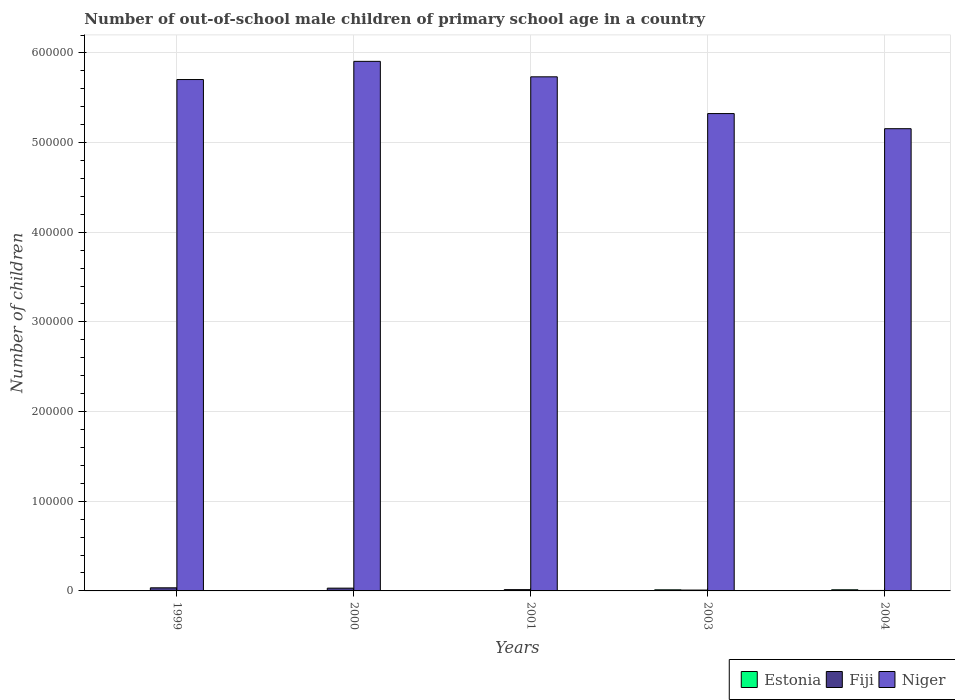How many groups of bars are there?
Make the answer very short. 5. What is the label of the 4th group of bars from the left?
Make the answer very short. 2003. What is the number of out-of-school male children in Niger in 1999?
Offer a very short reply. 5.70e+05. Across all years, what is the maximum number of out-of-school male children in Estonia?
Make the answer very short. 1269. Across all years, what is the minimum number of out-of-school male children in Niger?
Give a very brief answer. 5.16e+05. In which year was the number of out-of-school male children in Fiji minimum?
Make the answer very short. 2004. What is the total number of out-of-school male children in Niger in the graph?
Keep it short and to the point. 2.78e+06. What is the difference between the number of out-of-school male children in Estonia in 2003 and the number of out-of-school male children in Niger in 1999?
Make the answer very short. -5.69e+05. What is the average number of out-of-school male children in Estonia per year?
Ensure brevity in your answer.  509. In the year 2003, what is the difference between the number of out-of-school male children in Estonia and number of out-of-school male children in Niger?
Ensure brevity in your answer.  -5.31e+05. What is the ratio of the number of out-of-school male children in Estonia in 1999 to that in 2004?
Your answer should be compact. 0.02. Is the difference between the number of out-of-school male children in Estonia in 2000 and 2004 greater than the difference between the number of out-of-school male children in Niger in 2000 and 2004?
Ensure brevity in your answer.  No. What is the difference between the highest and the second highest number of out-of-school male children in Niger?
Your answer should be compact. 1.72e+04. What is the difference between the highest and the lowest number of out-of-school male children in Fiji?
Make the answer very short. 2933. What does the 3rd bar from the left in 2001 represents?
Make the answer very short. Niger. What does the 2nd bar from the right in 2001 represents?
Ensure brevity in your answer.  Fiji. How many bars are there?
Make the answer very short. 15. Are all the bars in the graph horizontal?
Your answer should be compact. No. Are the values on the major ticks of Y-axis written in scientific E-notation?
Your answer should be compact. No. Does the graph contain grids?
Offer a very short reply. Yes. How are the legend labels stacked?
Give a very brief answer. Horizontal. What is the title of the graph?
Offer a terse response. Number of out-of-school male children of primary school age in a country. What is the label or title of the Y-axis?
Give a very brief answer. Number of children. What is the Number of children in Estonia in 1999?
Make the answer very short. 27. What is the Number of children in Fiji in 1999?
Provide a succinct answer. 3458. What is the Number of children in Niger in 1999?
Give a very brief answer. 5.70e+05. What is the Number of children of Estonia in 2000?
Your answer should be very brief. 17. What is the Number of children of Fiji in 2000?
Your answer should be very brief. 3094. What is the Number of children of Niger in 2000?
Your answer should be compact. 5.91e+05. What is the Number of children in Fiji in 2001?
Your answer should be very brief. 1433. What is the Number of children in Niger in 2001?
Your answer should be very brief. 5.73e+05. What is the Number of children in Estonia in 2003?
Offer a very short reply. 1222. What is the Number of children in Fiji in 2003?
Give a very brief answer. 957. What is the Number of children in Niger in 2003?
Offer a terse response. 5.32e+05. What is the Number of children in Estonia in 2004?
Your response must be concise. 1269. What is the Number of children in Fiji in 2004?
Give a very brief answer. 525. What is the Number of children of Niger in 2004?
Make the answer very short. 5.16e+05. Across all years, what is the maximum Number of children in Estonia?
Offer a very short reply. 1269. Across all years, what is the maximum Number of children of Fiji?
Your answer should be very brief. 3458. Across all years, what is the maximum Number of children in Niger?
Offer a very short reply. 5.91e+05. Across all years, what is the minimum Number of children in Fiji?
Your response must be concise. 525. Across all years, what is the minimum Number of children of Niger?
Provide a short and direct response. 5.16e+05. What is the total Number of children of Estonia in the graph?
Offer a terse response. 2545. What is the total Number of children in Fiji in the graph?
Offer a very short reply. 9467. What is the total Number of children in Niger in the graph?
Ensure brevity in your answer.  2.78e+06. What is the difference between the Number of children of Fiji in 1999 and that in 2000?
Offer a terse response. 364. What is the difference between the Number of children in Niger in 1999 and that in 2000?
Offer a very short reply. -2.03e+04. What is the difference between the Number of children in Estonia in 1999 and that in 2001?
Make the answer very short. 17. What is the difference between the Number of children of Fiji in 1999 and that in 2001?
Make the answer very short. 2025. What is the difference between the Number of children of Niger in 1999 and that in 2001?
Make the answer very short. -3041. What is the difference between the Number of children in Estonia in 1999 and that in 2003?
Provide a short and direct response. -1195. What is the difference between the Number of children of Fiji in 1999 and that in 2003?
Give a very brief answer. 2501. What is the difference between the Number of children of Niger in 1999 and that in 2003?
Provide a short and direct response. 3.80e+04. What is the difference between the Number of children of Estonia in 1999 and that in 2004?
Give a very brief answer. -1242. What is the difference between the Number of children of Fiji in 1999 and that in 2004?
Offer a terse response. 2933. What is the difference between the Number of children in Niger in 1999 and that in 2004?
Offer a terse response. 5.48e+04. What is the difference between the Number of children of Fiji in 2000 and that in 2001?
Provide a short and direct response. 1661. What is the difference between the Number of children in Niger in 2000 and that in 2001?
Offer a terse response. 1.72e+04. What is the difference between the Number of children in Estonia in 2000 and that in 2003?
Offer a terse response. -1205. What is the difference between the Number of children in Fiji in 2000 and that in 2003?
Provide a short and direct response. 2137. What is the difference between the Number of children of Niger in 2000 and that in 2003?
Give a very brief answer. 5.82e+04. What is the difference between the Number of children of Estonia in 2000 and that in 2004?
Your answer should be very brief. -1252. What is the difference between the Number of children in Fiji in 2000 and that in 2004?
Make the answer very short. 2569. What is the difference between the Number of children of Niger in 2000 and that in 2004?
Your answer should be very brief. 7.51e+04. What is the difference between the Number of children in Estonia in 2001 and that in 2003?
Offer a terse response. -1212. What is the difference between the Number of children in Fiji in 2001 and that in 2003?
Make the answer very short. 476. What is the difference between the Number of children in Niger in 2001 and that in 2003?
Provide a succinct answer. 4.10e+04. What is the difference between the Number of children of Estonia in 2001 and that in 2004?
Ensure brevity in your answer.  -1259. What is the difference between the Number of children in Fiji in 2001 and that in 2004?
Keep it short and to the point. 908. What is the difference between the Number of children in Niger in 2001 and that in 2004?
Your response must be concise. 5.79e+04. What is the difference between the Number of children of Estonia in 2003 and that in 2004?
Ensure brevity in your answer.  -47. What is the difference between the Number of children in Fiji in 2003 and that in 2004?
Ensure brevity in your answer.  432. What is the difference between the Number of children of Niger in 2003 and that in 2004?
Your answer should be very brief. 1.69e+04. What is the difference between the Number of children in Estonia in 1999 and the Number of children in Fiji in 2000?
Provide a succinct answer. -3067. What is the difference between the Number of children of Estonia in 1999 and the Number of children of Niger in 2000?
Provide a succinct answer. -5.91e+05. What is the difference between the Number of children in Fiji in 1999 and the Number of children in Niger in 2000?
Give a very brief answer. -5.87e+05. What is the difference between the Number of children of Estonia in 1999 and the Number of children of Fiji in 2001?
Offer a terse response. -1406. What is the difference between the Number of children in Estonia in 1999 and the Number of children in Niger in 2001?
Provide a succinct answer. -5.73e+05. What is the difference between the Number of children in Fiji in 1999 and the Number of children in Niger in 2001?
Offer a very short reply. -5.70e+05. What is the difference between the Number of children in Estonia in 1999 and the Number of children in Fiji in 2003?
Provide a short and direct response. -930. What is the difference between the Number of children in Estonia in 1999 and the Number of children in Niger in 2003?
Offer a terse response. -5.32e+05. What is the difference between the Number of children of Fiji in 1999 and the Number of children of Niger in 2003?
Ensure brevity in your answer.  -5.29e+05. What is the difference between the Number of children of Estonia in 1999 and the Number of children of Fiji in 2004?
Your answer should be compact. -498. What is the difference between the Number of children of Estonia in 1999 and the Number of children of Niger in 2004?
Make the answer very short. -5.15e+05. What is the difference between the Number of children of Fiji in 1999 and the Number of children of Niger in 2004?
Offer a terse response. -5.12e+05. What is the difference between the Number of children of Estonia in 2000 and the Number of children of Fiji in 2001?
Provide a short and direct response. -1416. What is the difference between the Number of children of Estonia in 2000 and the Number of children of Niger in 2001?
Provide a succinct answer. -5.73e+05. What is the difference between the Number of children of Fiji in 2000 and the Number of children of Niger in 2001?
Offer a terse response. -5.70e+05. What is the difference between the Number of children of Estonia in 2000 and the Number of children of Fiji in 2003?
Provide a succinct answer. -940. What is the difference between the Number of children of Estonia in 2000 and the Number of children of Niger in 2003?
Provide a succinct answer. -5.32e+05. What is the difference between the Number of children of Fiji in 2000 and the Number of children of Niger in 2003?
Provide a succinct answer. -5.29e+05. What is the difference between the Number of children of Estonia in 2000 and the Number of children of Fiji in 2004?
Provide a short and direct response. -508. What is the difference between the Number of children of Estonia in 2000 and the Number of children of Niger in 2004?
Give a very brief answer. -5.15e+05. What is the difference between the Number of children of Fiji in 2000 and the Number of children of Niger in 2004?
Provide a short and direct response. -5.12e+05. What is the difference between the Number of children in Estonia in 2001 and the Number of children in Fiji in 2003?
Make the answer very short. -947. What is the difference between the Number of children in Estonia in 2001 and the Number of children in Niger in 2003?
Make the answer very short. -5.32e+05. What is the difference between the Number of children of Fiji in 2001 and the Number of children of Niger in 2003?
Offer a very short reply. -5.31e+05. What is the difference between the Number of children of Estonia in 2001 and the Number of children of Fiji in 2004?
Provide a succinct answer. -515. What is the difference between the Number of children of Estonia in 2001 and the Number of children of Niger in 2004?
Make the answer very short. -5.15e+05. What is the difference between the Number of children of Fiji in 2001 and the Number of children of Niger in 2004?
Your answer should be very brief. -5.14e+05. What is the difference between the Number of children in Estonia in 2003 and the Number of children in Fiji in 2004?
Keep it short and to the point. 697. What is the difference between the Number of children of Estonia in 2003 and the Number of children of Niger in 2004?
Your answer should be compact. -5.14e+05. What is the difference between the Number of children of Fiji in 2003 and the Number of children of Niger in 2004?
Provide a succinct answer. -5.15e+05. What is the average Number of children of Estonia per year?
Your answer should be compact. 509. What is the average Number of children of Fiji per year?
Provide a short and direct response. 1893.4. What is the average Number of children of Niger per year?
Offer a very short reply. 5.56e+05. In the year 1999, what is the difference between the Number of children of Estonia and Number of children of Fiji?
Your response must be concise. -3431. In the year 1999, what is the difference between the Number of children of Estonia and Number of children of Niger?
Your answer should be very brief. -5.70e+05. In the year 1999, what is the difference between the Number of children in Fiji and Number of children in Niger?
Offer a terse response. -5.67e+05. In the year 2000, what is the difference between the Number of children in Estonia and Number of children in Fiji?
Give a very brief answer. -3077. In the year 2000, what is the difference between the Number of children in Estonia and Number of children in Niger?
Offer a very short reply. -5.91e+05. In the year 2000, what is the difference between the Number of children of Fiji and Number of children of Niger?
Ensure brevity in your answer.  -5.88e+05. In the year 2001, what is the difference between the Number of children in Estonia and Number of children in Fiji?
Make the answer very short. -1423. In the year 2001, what is the difference between the Number of children of Estonia and Number of children of Niger?
Ensure brevity in your answer.  -5.73e+05. In the year 2001, what is the difference between the Number of children of Fiji and Number of children of Niger?
Keep it short and to the point. -5.72e+05. In the year 2003, what is the difference between the Number of children of Estonia and Number of children of Fiji?
Give a very brief answer. 265. In the year 2003, what is the difference between the Number of children of Estonia and Number of children of Niger?
Keep it short and to the point. -5.31e+05. In the year 2003, what is the difference between the Number of children of Fiji and Number of children of Niger?
Your answer should be compact. -5.31e+05. In the year 2004, what is the difference between the Number of children of Estonia and Number of children of Fiji?
Provide a succinct answer. 744. In the year 2004, what is the difference between the Number of children in Estonia and Number of children in Niger?
Your answer should be very brief. -5.14e+05. In the year 2004, what is the difference between the Number of children in Fiji and Number of children in Niger?
Your response must be concise. -5.15e+05. What is the ratio of the Number of children of Estonia in 1999 to that in 2000?
Ensure brevity in your answer.  1.59. What is the ratio of the Number of children in Fiji in 1999 to that in 2000?
Give a very brief answer. 1.12. What is the ratio of the Number of children of Niger in 1999 to that in 2000?
Make the answer very short. 0.97. What is the ratio of the Number of children in Estonia in 1999 to that in 2001?
Offer a terse response. 2.7. What is the ratio of the Number of children of Fiji in 1999 to that in 2001?
Make the answer very short. 2.41. What is the ratio of the Number of children of Estonia in 1999 to that in 2003?
Provide a short and direct response. 0.02. What is the ratio of the Number of children of Fiji in 1999 to that in 2003?
Your answer should be very brief. 3.61. What is the ratio of the Number of children of Niger in 1999 to that in 2003?
Provide a succinct answer. 1.07. What is the ratio of the Number of children in Estonia in 1999 to that in 2004?
Make the answer very short. 0.02. What is the ratio of the Number of children of Fiji in 1999 to that in 2004?
Provide a short and direct response. 6.59. What is the ratio of the Number of children in Niger in 1999 to that in 2004?
Your response must be concise. 1.11. What is the ratio of the Number of children of Fiji in 2000 to that in 2001?
Provide a succinct answer. 2.16. What is the ratio of the Number of children in Niger in 2000 to that in 2001?
Your response must be concise. 1.03. What is the ratio of the Number of children of Estonia in 2000 to that in 2003?
Offer a very short reply. 0.01. What is the ratio of the Number of children of Fiji in 2000 to that in 2003?
Ensure brevity in your answer.  3.23. What is the ratio of the Number of children of Niger in 2000 to that in 2003?
Keep it short and to the point. 1.11. What is the ratio of the Number of children of Estonia in 2000 to that in 2004?
Your answer should be very brief. 0.01. What is the ratio of the Number of children in Fiji in 2000 to that in 2004?
Offer a very short reply. 5.89. What is the ratio of the Number of children in Niger in 2000 to that in 2004?
Provide a short and direct response. 1.15. What is the ratio of the Number of children in Estonia in 2001 to that in 2003?
Ensure brevity in your answer.  0.01. What is the ratio of the Number of children in Fiji in 2001 to that in 2003?
Give a very brief answer. 1.5. What is the ratio of the Number of children in Niger in 2001 to that in 2003?
Your answer should be compact. 1.08. What is the ratio of the Number of children of Estonia in 2001 to that in 2004?
Offer a very short reply. 0.01. What is the ratio of the Number of children of Fiji in 2001 to that in 2004?
Offer a terse response. 2.73. What is the ratio of the Number of children of Niger in 2001 to that in 2004?
Offer a very short reply. 1.11. What is the ratio of the Number of children of Estonia in 2003 to that in 2004?
Offer a terse response. 0.96. What is the ratio of the Number of children in Fiji in 2003 to that in 2004?
Give a very brief answer. 1.82. What is the ratio of the Number of children of Niger in 2003 to that in 2004?
Give a very brief answer. 1.03. What is the difference between the highest and the second highest Number of children in Estonia?
Provide a succinct answer. 47. What is the difference between the highest and the second highest Number of children of Fiji?
Give a very brief answer. 364. What is the difference between the highest and the second highest Number of children of Niger?
Offer a very short reply. 1.72e+04. What is the difference between the highest and the lowest Number of children in Estonia?
Give a very brief answer. 1259. What is the difference between the highest and the lowest Number of children in Fiji?
Your answer should be compact. 2933. What is the difference between the highest and the lowest Number of children in Niger?
Give a very brief answer. 7.51e+04. 